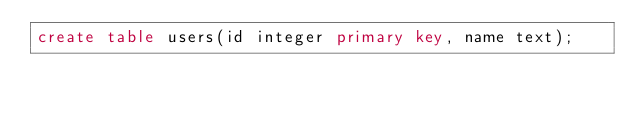<code> <loc_0><loc_0><loc_500><loc_500><_SQL_>create table users(id integer primary key, name text);</code> 